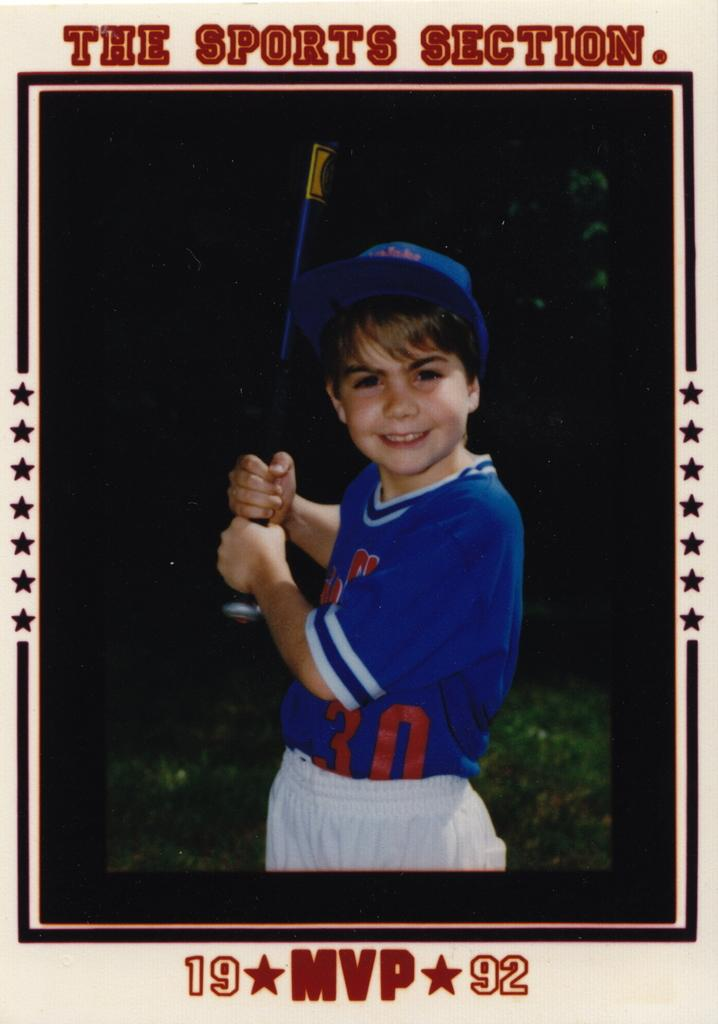<image>
Provide a brief description of the given image. A baseball card-style photo shows a young boy wearing the number 30. 